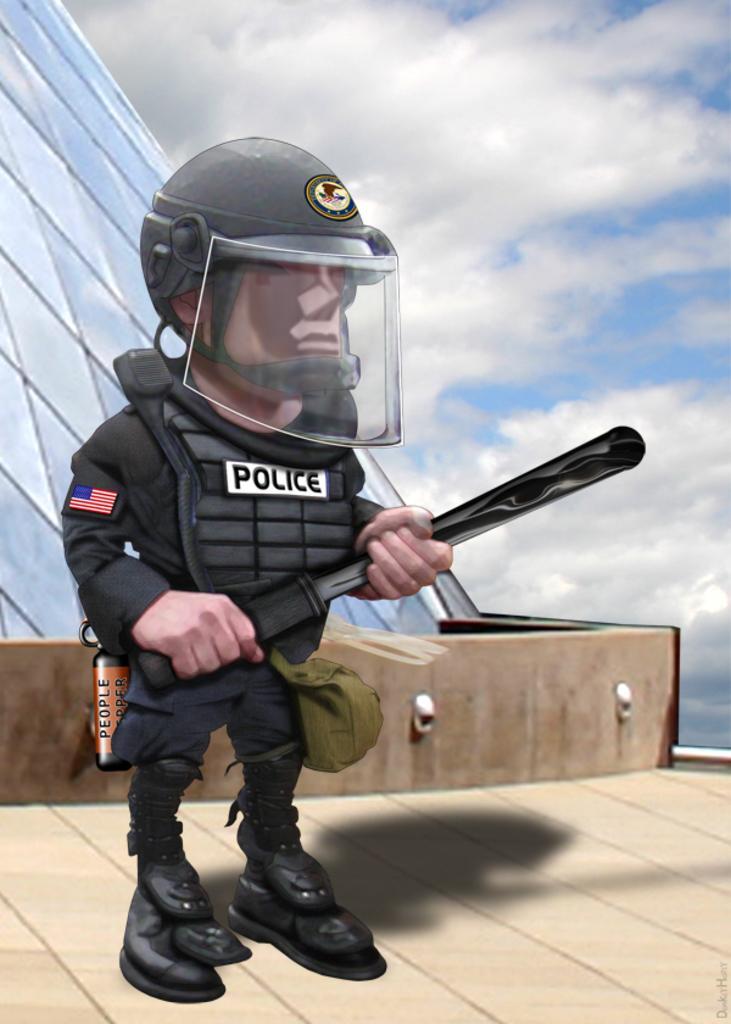Could you give a brief overview of what you see in this image? This is animated picture,there is a man standing and holding an object and wore helmet. We can see glass and wall. In the background we can see sky with clouds. 